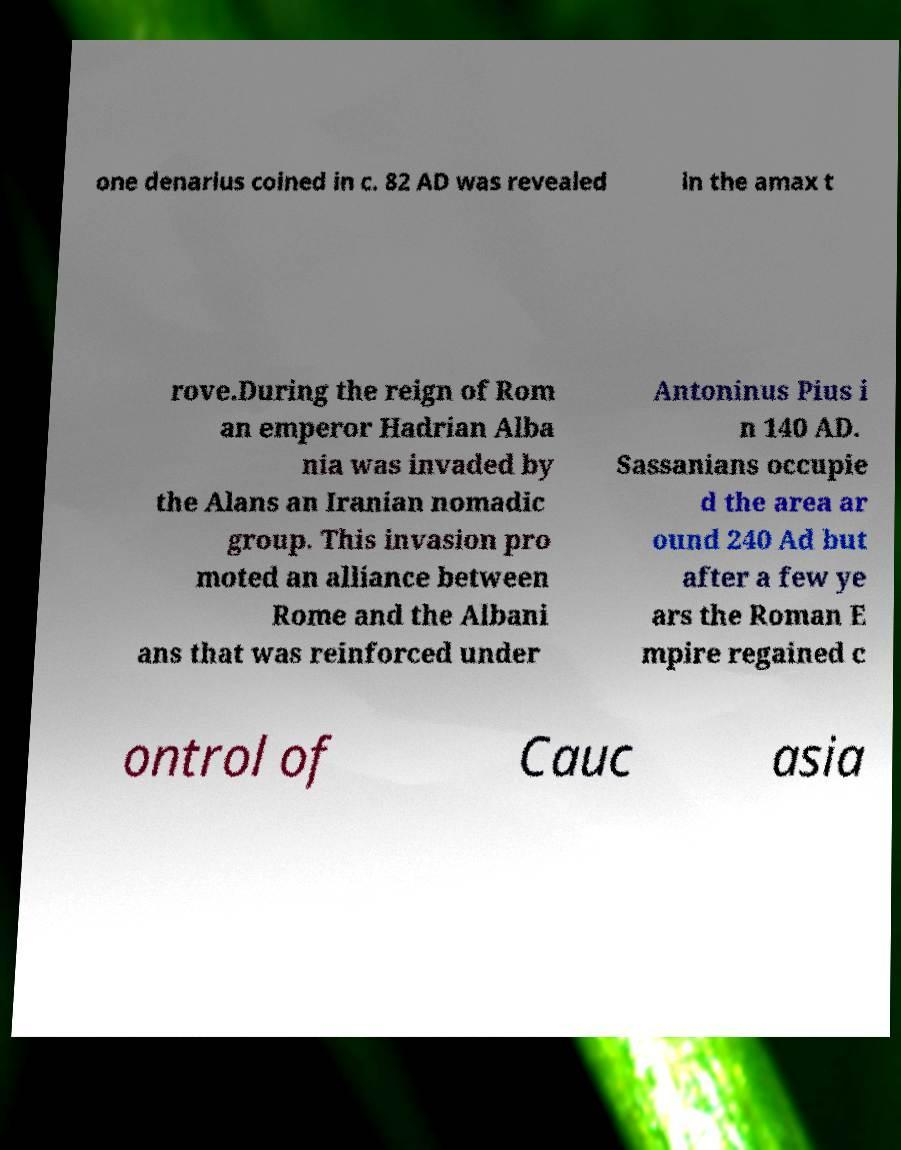Please read and relay the text visible in this image. What does it say? one denarius coined in c. 82 AD was revealed in the amax t rove.During the reign of Rom an emperor Hadrian Alba nia was invaded by the Alans an Iranian nomadic group. This invasion pro moted an alliance between Rome and the Albani ans that was reinforced under Antoninus Pius i n 140 AD. Sassanians occupie d the area ar ound 240 Ad but after a few ye ars the Roman E mpire regained c ontrol of Cauc asia 